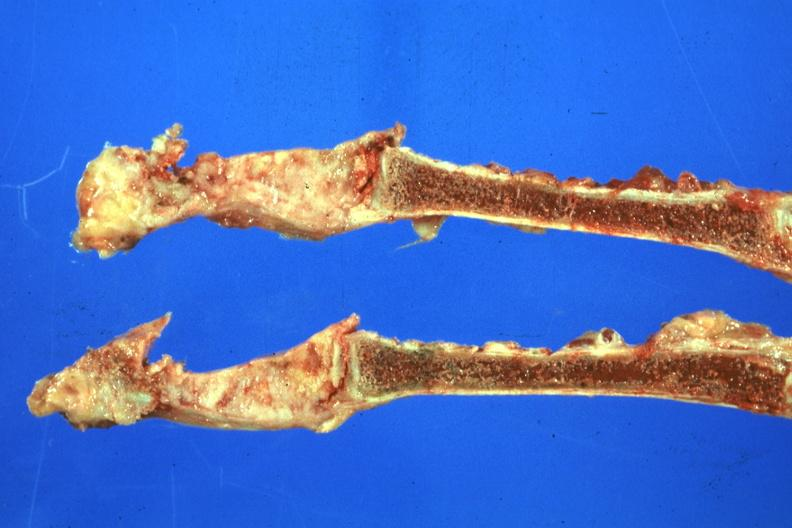what is present?
Answer the question using a single word or phrase. Joints 